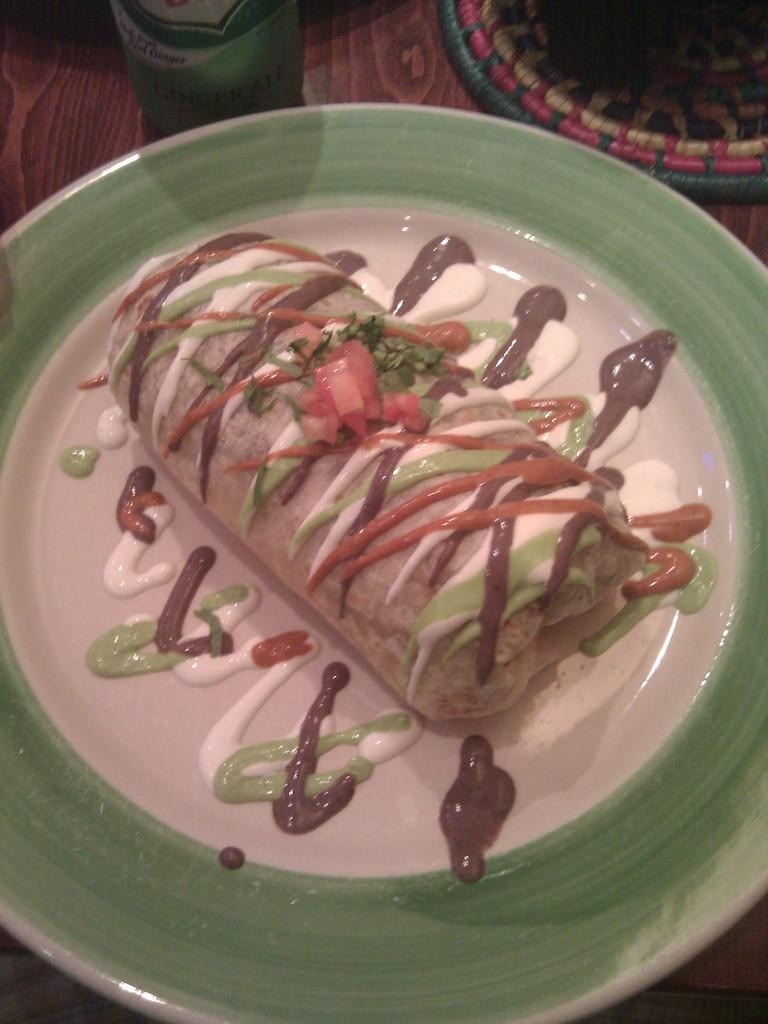What is on the plate that is visible in the image? There is food on a plate in the image. What else can be seen in the background of the image? There is a bottle and a mat on the table in the background of the image. How many eyes can be seen on the grass in the image? There is no grass present in the image, and therefore no eyes can be seen on it. 